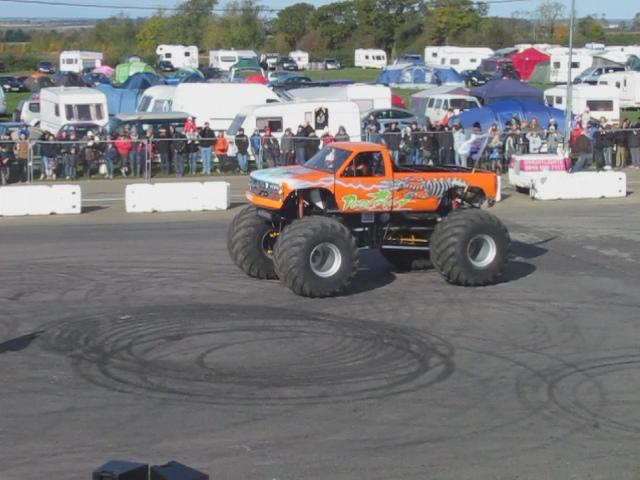What are the circular patterns on the ground?

Choices:
A) tire tracks
B) paint
C) abstract drawing
D) ink tire tracks 